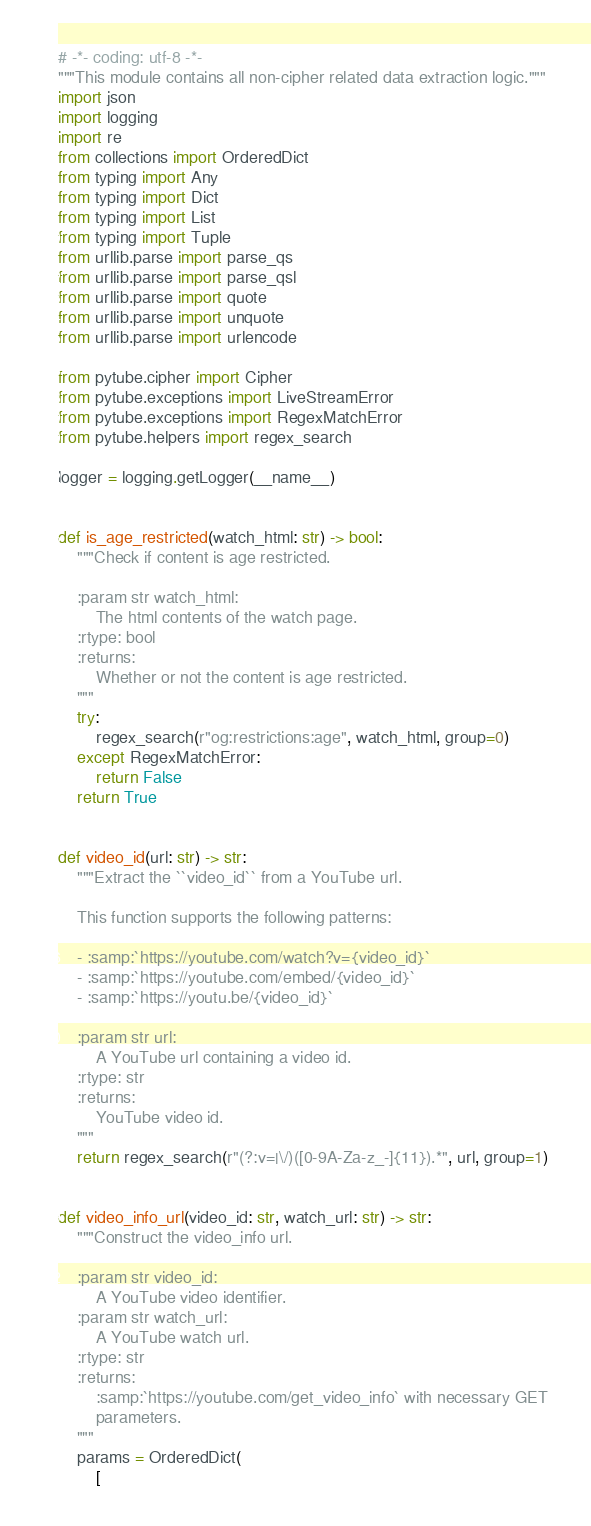<code> <loc_0><loc_0><loc_500><loc_500><_Python_># -*- coding: utf-8 -*-
"""This module contains all non-cipher related data extraction logic."""
import json
import logging
import re
from collections import OrderedDict
from typing import Any
from typing import Dict
from typing import List
from typing import Tuple
from urllib.parse import parse_qs
from urllib.parse import parse_qsl
from urllib.parse import quote
from urllib.parse import unquote
from urllib.parse import urlencode

from pytube.cipher import Cipher
from pytube.exceptions import LiveStreamError
from pytube.exceptions import RegexMatchError
from pytube.helpers import regex_search

logger = logging.getLogger(__name__)


def is_age_restricted(watch_html: str) -> bool:
    """Check if content is age restricted.

    :param str watch_html:
        The html contents of the watch page.
    :rtype: bool
    :returns:
        Whether or not the content is age restricted.
    """
    try:
        regex_search(r"og:restrictions:age", watch_html, group=0)
    except RegexMatchError:
        return False
    return True


def video_id(url: str) -> str:
    """Extract the ``video_id`` from a YouTube url.

    This function supports the following patterns:

    - :samp:`https://youtube.com/watch?v={video_id}`
    - :samp:`https://youtube.com/embed/{video_id}`
    - :samp:`https://youtu.be/{video_id}`

    :param str url:
        A YouTube url containing a video id.
    :rtype: str
    :returns:
        YouTube video id.
    """
    return regex_search(r"(?:v=|\/)([0-9A-Za-z_-]{11}).*", url, group=1)


def video_info_url(video_id: str, watch_url: str) -> str:
    """Construct the video_info url.

    :param str video_id:
        A YouTube video identifier.
    :param str watch_url:
        A YouTube watch url.
    :rtype: str
    :returns:
        :samp:`https://youtube.com/get_video_info` with necessary GET
        parameters.
    """
    params = OrderedDict(
        [</code> 